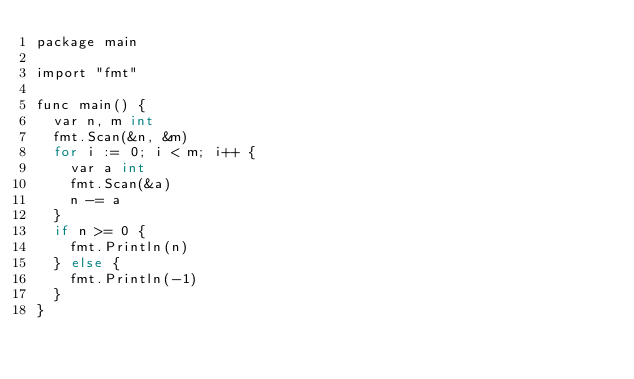Convert code to text. <code><loc_0><loc_0><loc_500><loc_500><_C_>package main

import "fmt"

func main() {
	var n, m int
	fmt.Scan(&n, &m)
	for i := 0; i < m; i++ {
		var a int
		fmt.Scan(&a)
		n -= a
	}
	if n >= 0 {
		fmt.Println(n)
	} else {
		fmt.Println(-1)
	}
}
</code> 